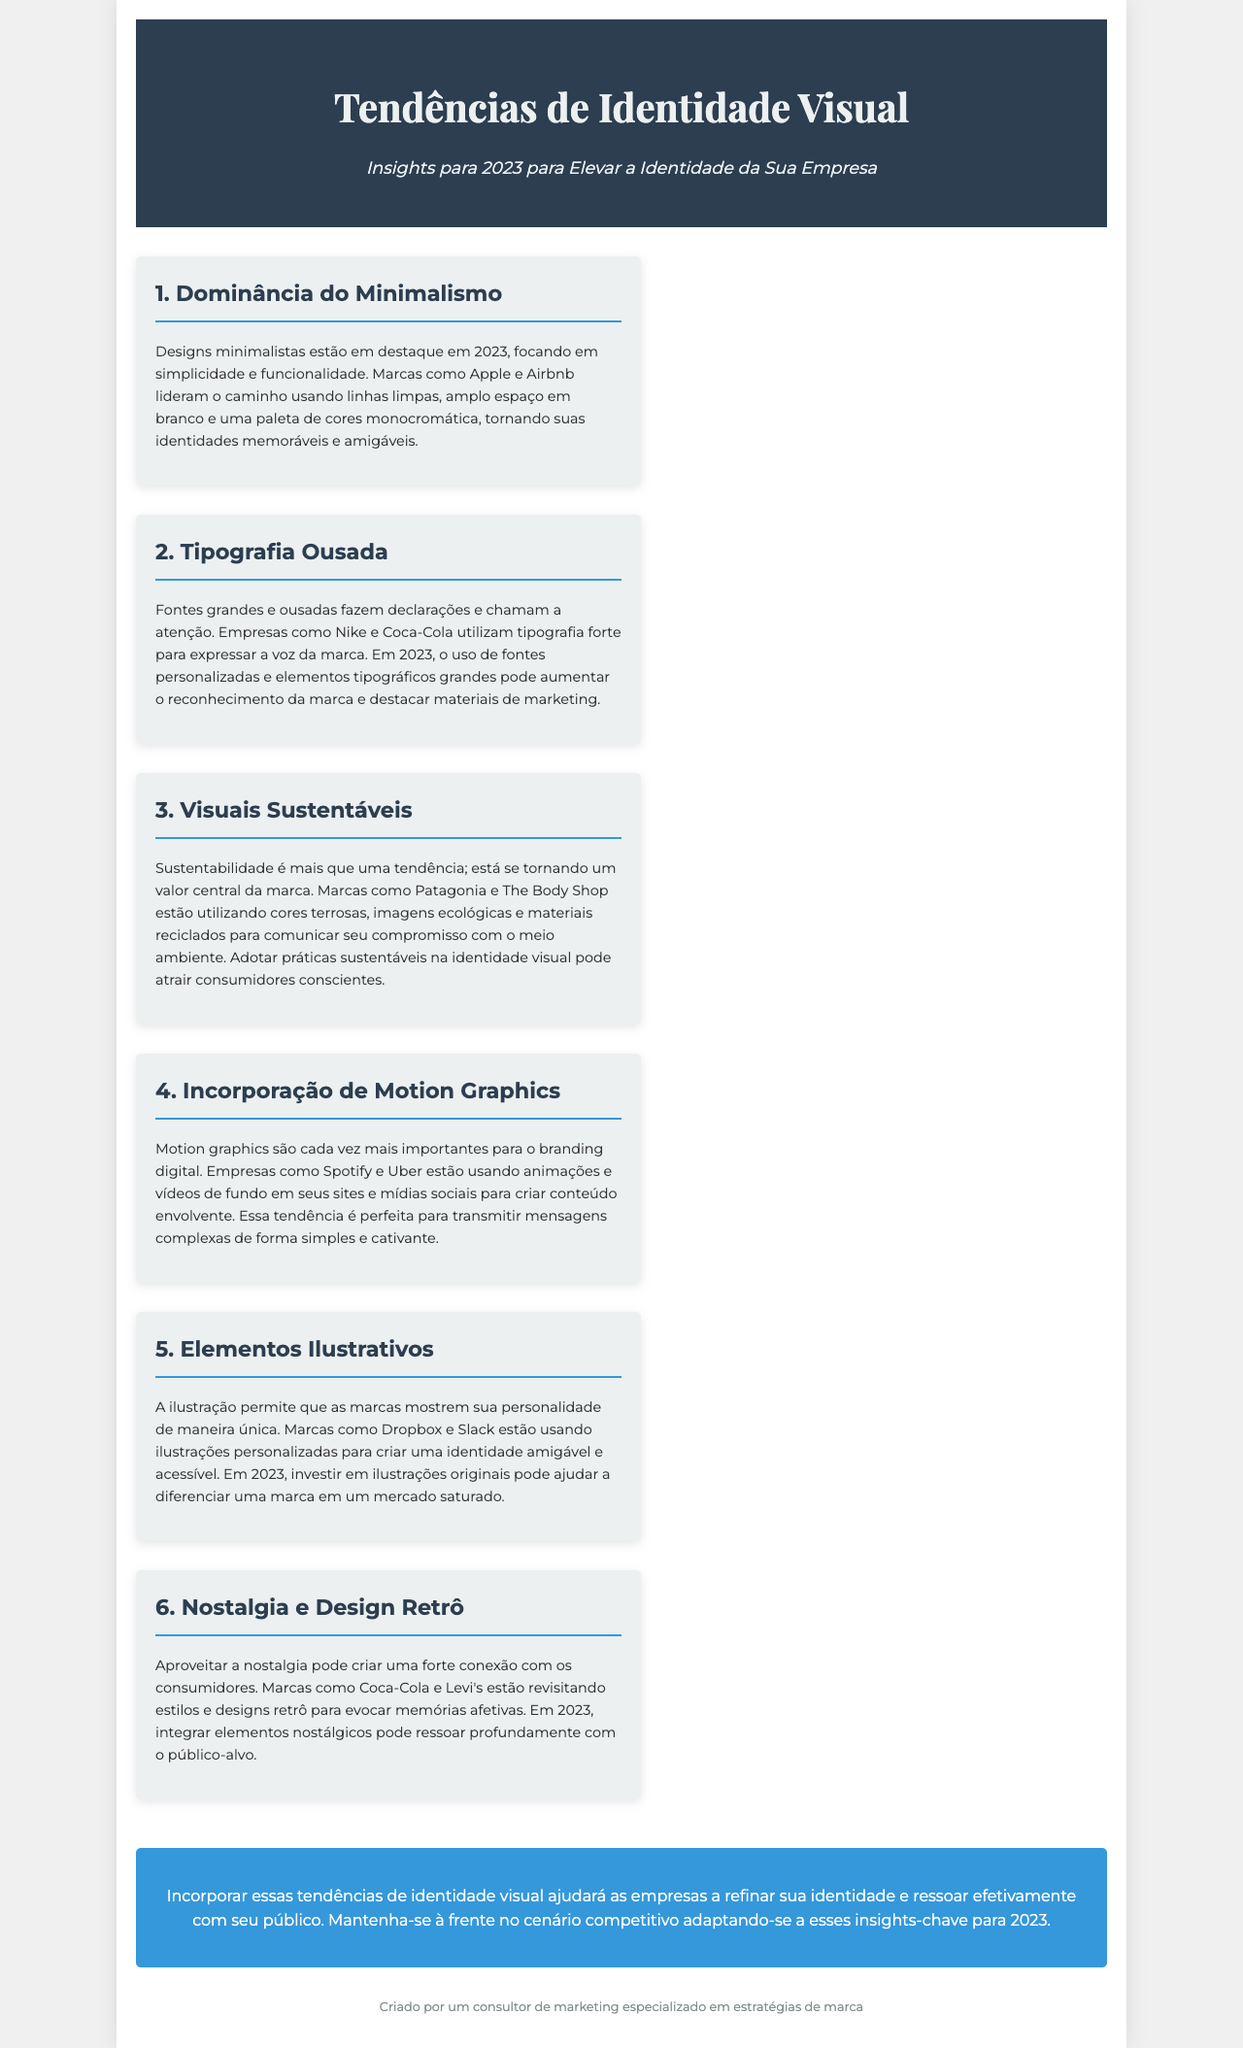qual é o título do documento? O título do documento é o cabeçalho principal apresentado na parte superior do material.
Answer: Tendências de Identidade Visual qual é a primeira tendência apresentada? A primeira tendência é a primeira seção do conteúdo, listada por ordem.
Answer: Dominância do Minimalismo quais marcas são mencionadas como exemplos da tipografia ousada? As marcas mencionadas são aquelas que utilizam essa característica em seus designs.
Answer: Nike e Coca-Cola como a sustentabilidade é abordada no documento? A sustentabilidade é discutida como uma das tendências, com ênfase em valores centrais da marca.
Answer: Visuais Sustentáveis o que caracteriza os elementos ilustrativos conforme descrito? A caracterização dos elementos ilustrativos é encontrada na seção que discute essa tendência.
Answer: Personalização da identidade quais marcas são citadas como exemplos que utilizam nostalgia? As marcas citadas são aquelas que revisitam estilos e designs para criar conexão emocional.
Answer: Coca-Cola e Levi's qual é a cor de fundo do fechamento do documento? A cor de fundo do fechamento é mencionada na seção de fechamento do conteúdo.
Answer: Azul quantas seções de tendência existem no documento? O número de seções de tendência pode ser contado a partir das listas apresentadas.
Answer: Seis 